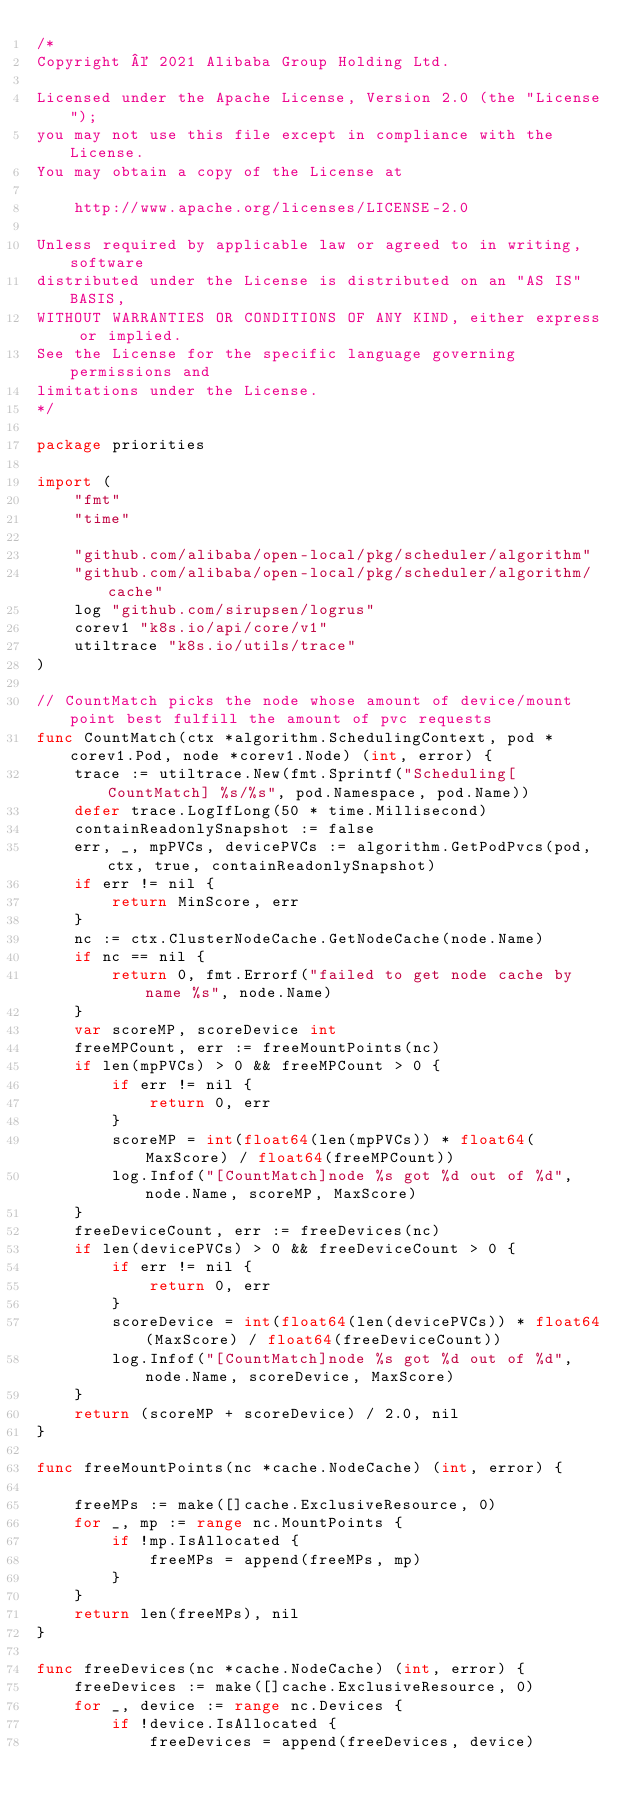<code> <loc_0><loc_0><loc_500><loc_500><_Go_>/*
Copyright © 2021 Alibaba Group Holding Ltd.

Licensed under the Apache License, Version 2.0 (the "License");
you may not use this file except in compliance with the License.
You may obtain a copy of the License at

    http://www.apache.org/licenses/LICENSE-2.0

Unless required by applicable law or agreed to in writing, software
distributed under the License is distributed on an "AS IS" BASIS,
WITHOUT WARRANTIES OR CONDITIONS OF ANY KIND, either express or implied.
See the License for the specific language governing permissions and
limitations under the License.
*/

package priorities

import (
	"fmt"
	"time"

	"github.com/alibaba/open-local/pkg/scheduler/algorithm"
	"github.com/alibaba/open-local/pkg/scheduler/algorithm/cache"
	log "github.com/sirupsen/logrus"
	corev1 "k8s.io/api/core/v1"
	utiltrace "k8s.io/utils/trace"
)

// CountMatch picks the node whose amount of device/mount point best fulfill the amount of pvc requests
func CountMatch(ctx *algorithm.SchedulingContext, pod *corev1.Pod, node *corev1.Node) (int, error) {
	trace := utiltrace.New(fmt.Sprintf("Scheduling[CountMatch] %s/%s", pod.Namespace, pod.Name))
	defer trace.LogIfLong(50 * time.Millisecond)
	containReadonlySnapshot := false
	err, _, mpPVCs, devicePVCs := algorithm.GetPodPvcs(pod, ctx, true, containReadonlySnapshot)
	if err != nil {
		return MinScore, err
	}
	nc := ctx.ClusterNodeCache.GetNodeCache(node.Name)
	if nc == nil {
		return 0, fmt.Errorf("failed to get node cache by name %s", node.Name)
	}
	var scoreMP, scoreDevice int
	freeMPCount, err := freeMountPoints(nc)
	if len(mpPVCs) > 0 && freeMPCount > 0 {
		if err != nil {
			return 0, err
		}
		scoreMP = int(float64(len(mpPVCs)) * float64(MaxScore) / float64(freeMPCount))
		log.Infof("[CountMatch]node %s got %d out of %d", node.Name, scoreMP, MaxScore)
	}
	freeDeviceCount, err := freeDevices(nc)
	if len(devicePVCs) > 0 && freeDeviceCount > 0 {
		if err != nil {
			return 0, err
		}
		scoreDevice = int(float64(len(devicePVCs)) * float64(MaxScore) / float64(freeDeviceCount))
		log.Infof("[CountMatch]node %s got %d out of %d", node.Name, scoreDevice, MaxScore)
	}
	return (scoreMP + scoreDevice) / 2.0, nil
}

func freeMountPoints(nc *cache.NodeCache) (int, error) {

	freeMPs := make([]cache.ExclusiveResource, 0)
	for _, mp := range nc.MountPoints {
		if !mp.IsAllocated {
			freeMPs = append(freeMPs, mp)
		}
	}
	return len(freeMPs), nil
}

func freeDevices(nc *cache.NodeCache) (int, error) {
	freeDevices := make([]cache.ExclusiveResource, 0)
	for _, device := range nc.Devices {
		if !device.IsAllocated {
			freeDevices = append(freeDevices, device)</code> 